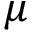Convert formula to latex. <formula><loc_0><loc_0><loc_500><loc_500>\mu</formula> 